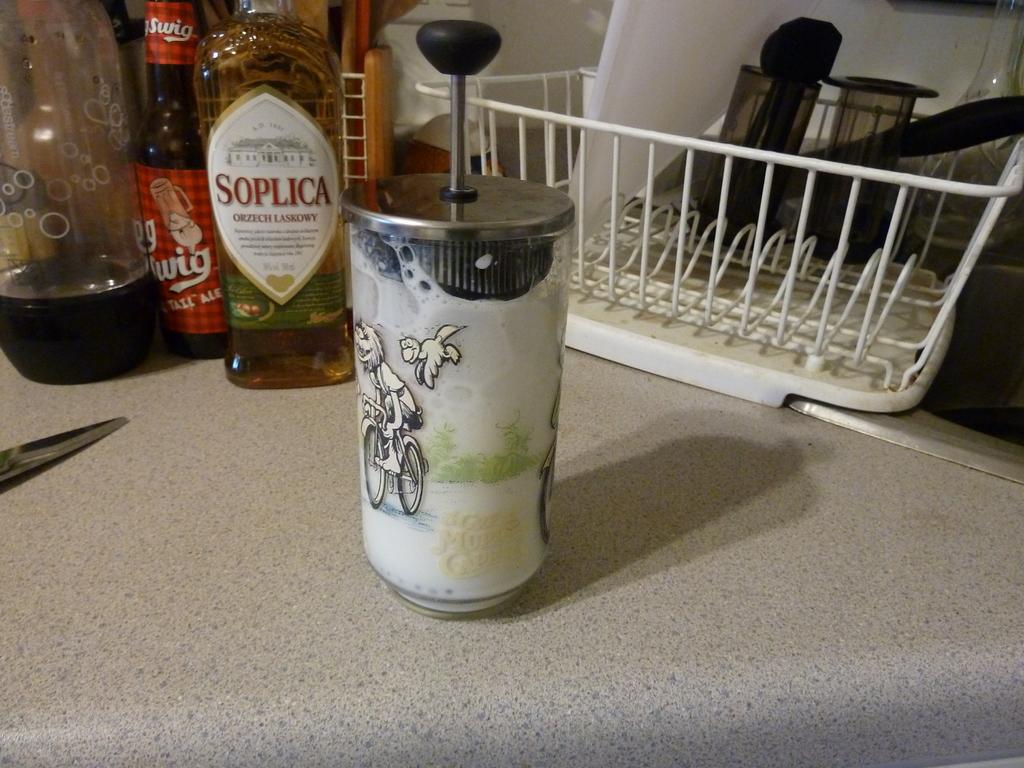What is the name on the tan bottle in the back?
Your response must be concise. Soplica. What is on the red label?
Ensure brevity in your answer.  Swig. 